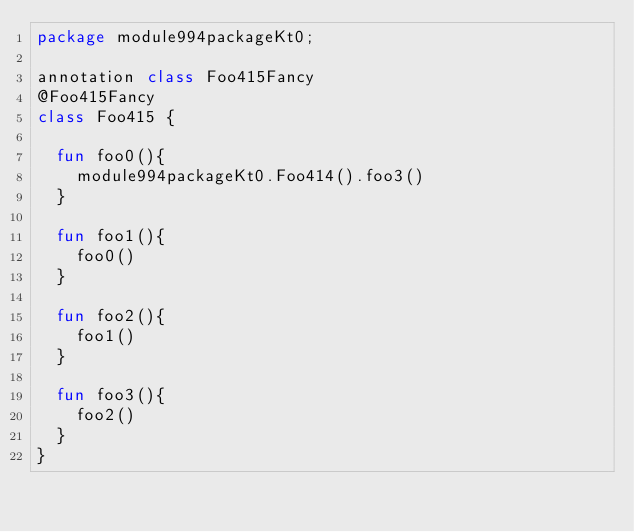Convert code to text. <code><loc_0><loc_0><loc_500><loc_500><_Kotlin_>package module994packageKt0;

annotation class Foo415Fancy
@Foo415Fancy
class Foo415 {

  fun foo0(){
    module994packageKt0.Foo414().foo3()
  }

  fun foo1(){
    foo0()
  }

  fun foo2(){
    foo1()
  }

  fun foo3(){
    foo2()
  }
}</code> 